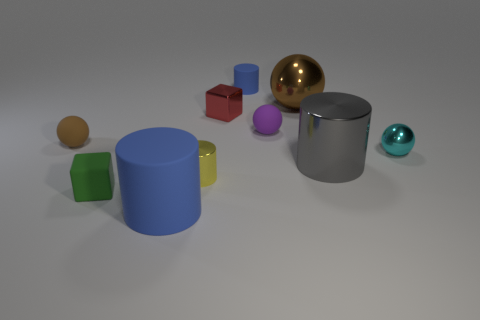There is a blue matte thing in front of the matte block; is its size the same as the small yellow object?
Give a very brief answer. No. How many other things are the same shape as the small purple matte object?
Offer a very short reply. 3. How many blue things are metallic cubes or rubber cylinders?
Your answer should be very brief. 2. There is a ball left of the small blue cylinder; is its color the same as the large metal cylinder?
Give a very brief answer. No. What is the shape of the large blue object that is made of the same material as the tiny blue thing?
Ensure brevity in your answer.  Cylinder. There is a big thing that is both in front of the cyan thing and behind the tiny green rubber cube; what color is it?
Offer a very short reply. Gray. There is a blue rubber cylinder to the right of the blue cylinder in front of the big brown thing; how big is it?
Provide a succinct answer. Small. Are there any metallic cylinders of the same color as the rubber cube?
Keep it short and to the point. No. Are there the same number of purple rubber things to the left of the red metal thing and brown matte cubes?
Provide a succinct answer. Yes. What number of tiny yellow cylinders are there?
Offer a terse response. 1. 